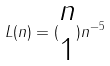<formula> <loc_0><loc_0><loc_500><loc_500>L ( n ) = ( \begin{matrix} n \\ 1 \end{matrix} ) n ^ { - 5 }</formula> 